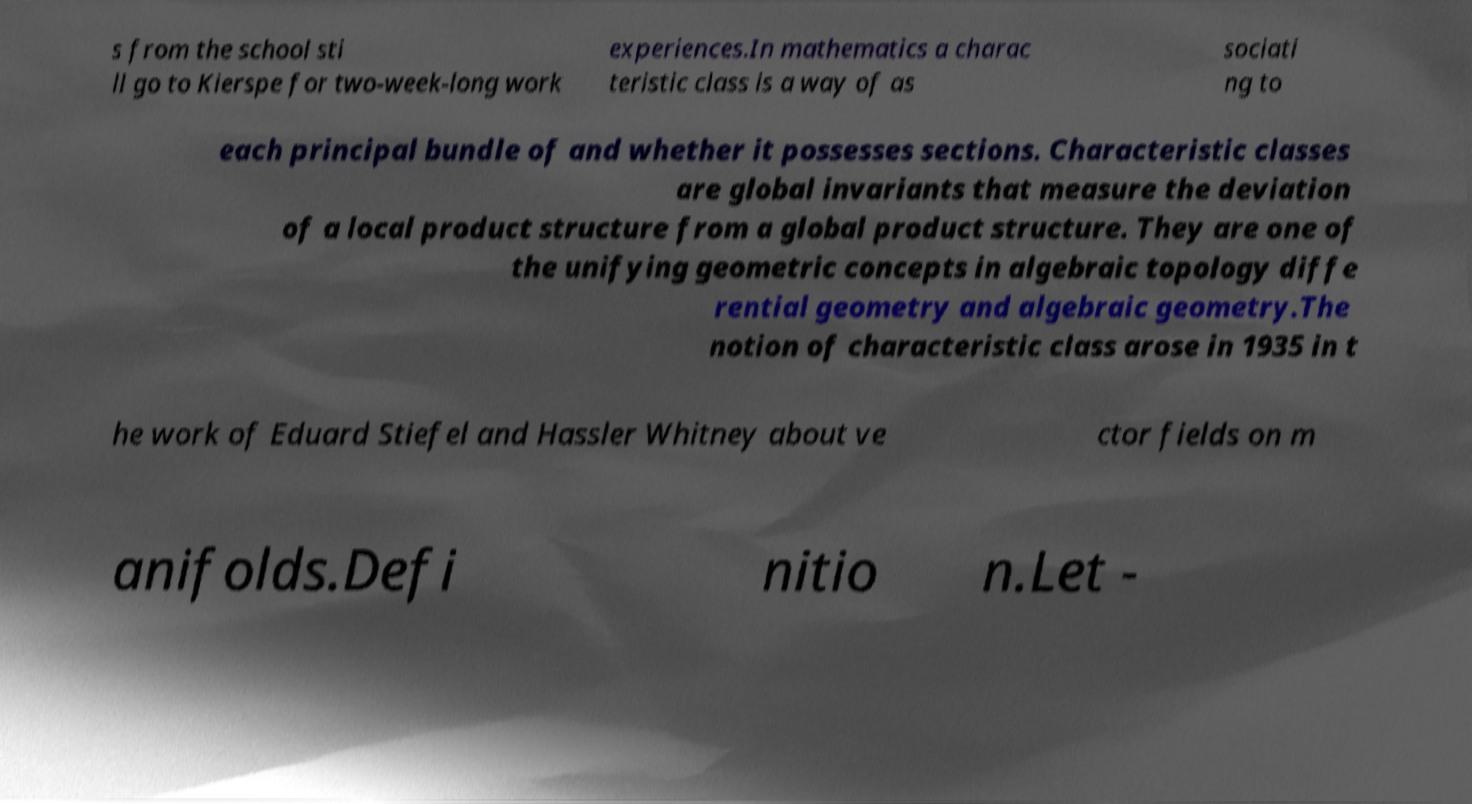There's text embedded in this image that I need extracted. Can you transcribe it verbatim? s from the school sti ll go to Kierspe for two-week-long work experiences.In mathematics a charac teristic class is a way of as sociati ng to each principal bundle of and whether it possesses sections. Characteristic classes are global invariants that measure the deviation of a local product structure from a global product structure. They are one of the unifying geometric concepts in algebraic topology diffe rential geometry and algebraic geometry.The notion of characteristic class arose in 1935 in t he work of Eduard Stiefel and Hassler Whitney about ve ctor fields on m anifolds.Defi nitio n.Let - 